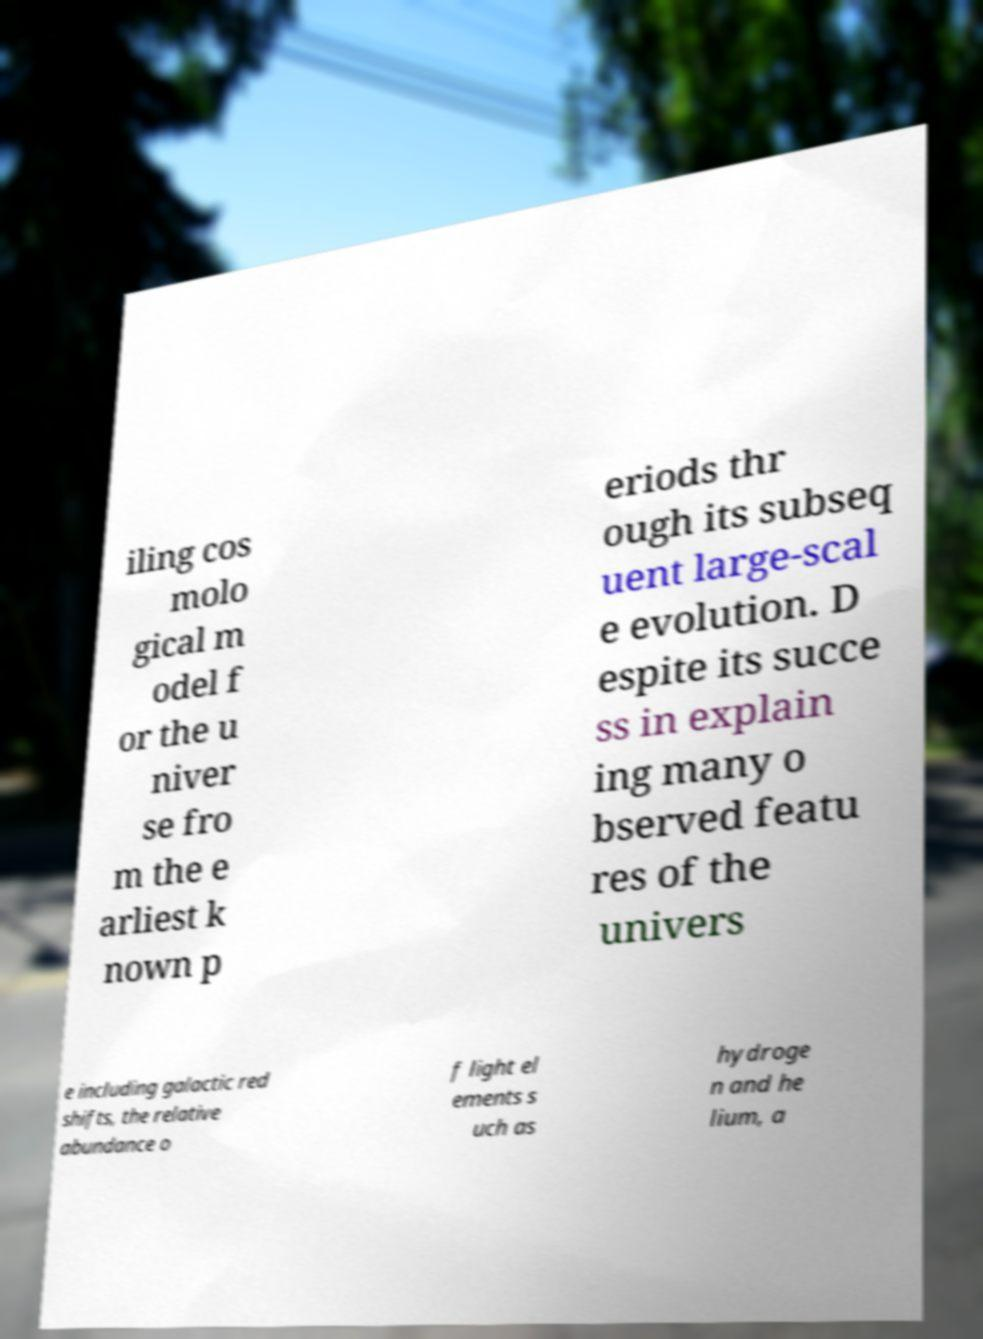Could you assist in decoding the text presented in this image and type it out clearly? iling cos molo gical m odel f or the u niver se fro m the e arliest k nown p eriods thr ough its subseq uent large-scal e evolution. D espite its succe ss in explain ing many o bserved featu res of the univers e including galactic red shifts, the relative abundance o f light el ements s uch as hydroge n and he lium, a 